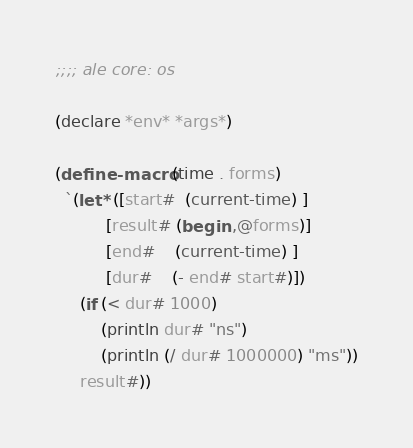<code> <loc_0><loc_0><loc_500><loc_500><_Scheme_>;;;; ale core: os

(declare *env* *args*)

(define-macro (time . forms)
  `(let* ([start#  (current-time) ]
          [result# (begin ,@forms)]
          [end#    (current-time) ]
          [dur#    (- end# start#)])
     (if (< dur# 1000)
         (println dur# "ns")
         (println (/ dur# 1000000) "ms"))
     result#))
</code> 